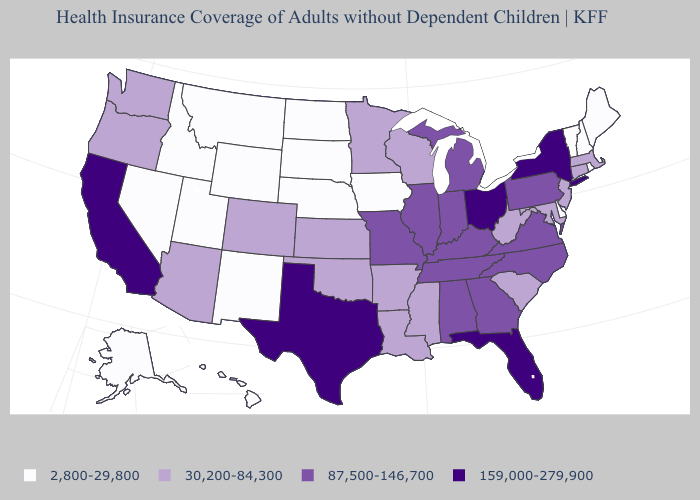Name the states that have a value in the range 2,800-29,800?
Quick response, please. Alaska, Delaware, Hawaii, Idaho, Iowa, Maine, Montana, Nebraska, Nevada, New Hampshire, New Mexico, North Dakota, Rhode Island, South Dakota, Utah, Vermont, Wyoming. What is the highest value in the USA?
Write a very short answer. 159,000-279,900. What is the value of Colorado?
Write a very short answer. 30,200-84,300. What is the value of Florida?
Be succinct. 159,000-279,900. Name the states that have a value in the range 159,000-279,900?
Give a very brief answer. California, Florida, New York, Ohio, Texas. Which states have the lowest value in the USA?
Write a very short answer. Alaska, Delaware, Hawaii, Idaho, Iowa, Maine, Montana, Nebraska, Nevada, New Hampshire, New Mexico, North Dakota, Rhode Island, South Dakota, Utah, Vermont, Wyoming. Does Delaware have the lowest value in the South?
Be succinct. Yes. What is the highest value in the South ?
Be succinct. 159,000-279,900. Does New York have the highest value in the Northeast?
Quick response, please. Yes. Among the states that border Maryland , does Delaware have the lowest value?
Keep it brief. Yes. Which states have the lowest value in the West?
Write a very short answer. Alaska, Hawaii, Idaho, Montana, Nevada, New Mexico, Utah, Wyoming. What is the lowest value in states that border Indiana?
Write a very short answer. 87,500-146,700. What is the value of Indiana?
Concise answer only. 87,500-146,700. Name the states that have a value in the range 2,800-29,800?
Answer briefly. Alaska, Delaware, Hawaii, Idaho, Iowa, Maine, Montana, Nebraska, Nevada, New Hampshire, New Mexico, North Dakota, Rhode Island, South Dakota, Utah, Vermont, Wyoming. What is the value of Vermont?
Keep it brief. 2,800-29,800. 